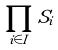Convert formula to latex. <formula><loc_0><loc_0><loc_500><loc_500>\prod _ { i \in I } S _ { i }</formula> 